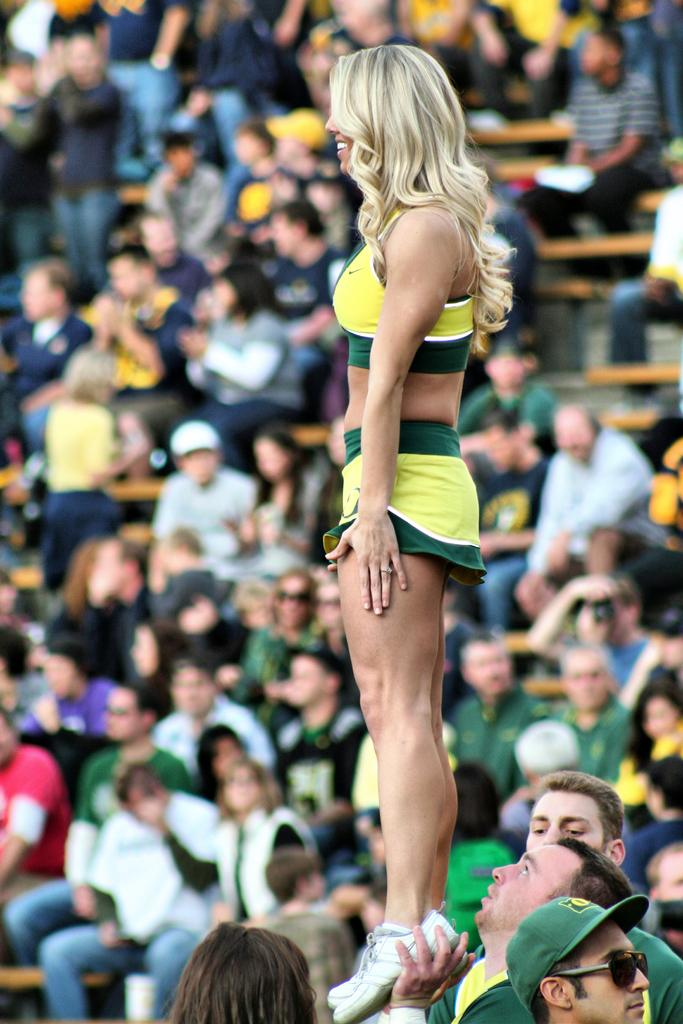What is happening in the foreground of the image? In the foreground of the image, one person is lifting another person. How many people are involved in this action? Two people are involved in this action. What is the general setting of the image? There are many people sitting in the background of the image. What type of table is being used by the person lifting the other person in the image? There is no table present in the image; it features two people interacting without any furniture. How many roses can be seen on the person being lifted in the image? There are no roses visible on the person being lifted in the image. 